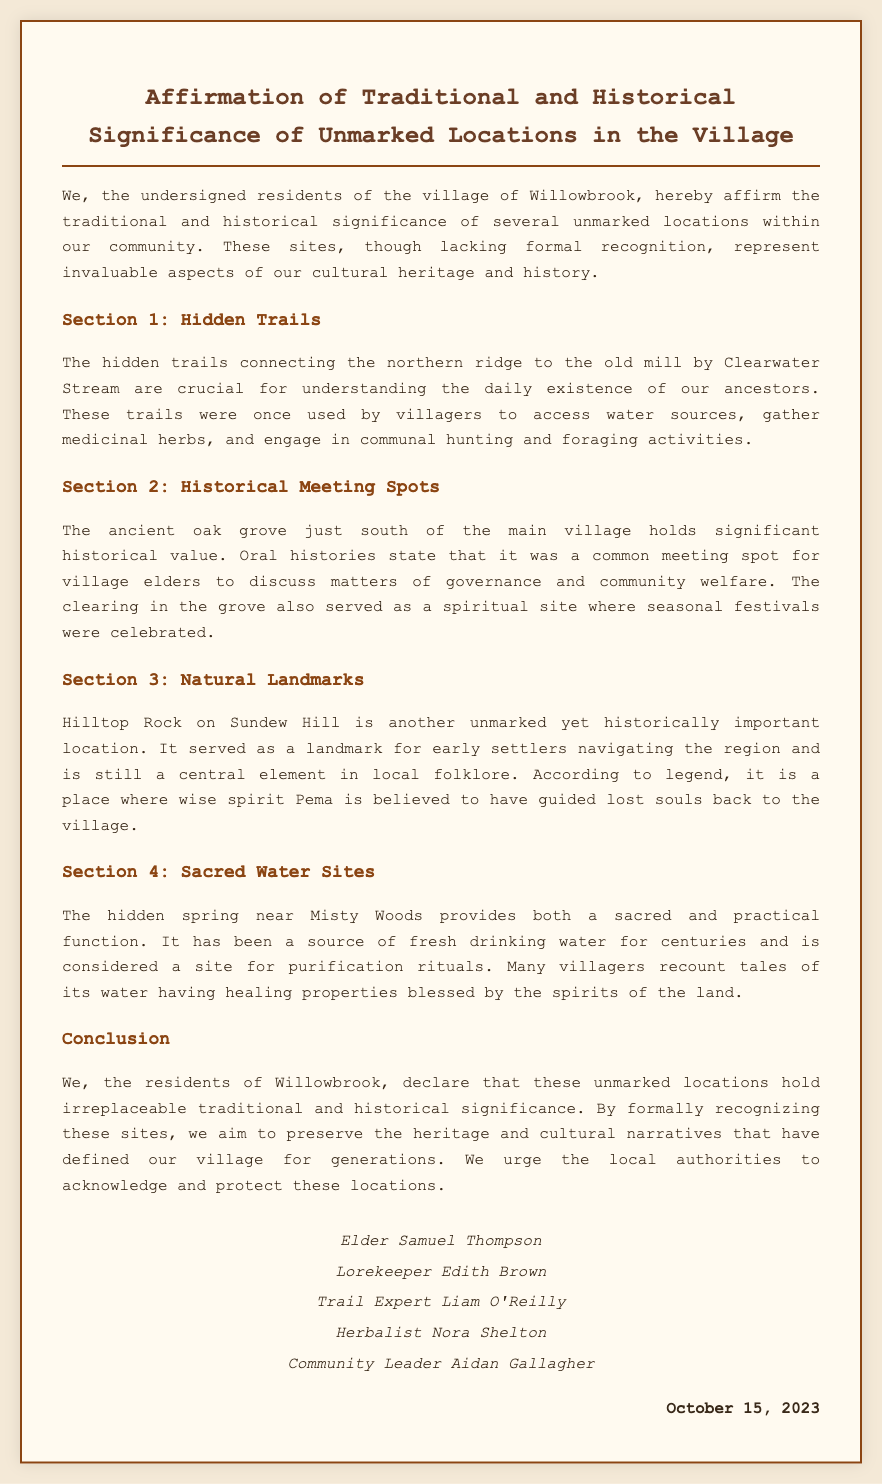What is the title of the document? The title is clearly stated at the top of the document.
Answer: Affirmation of Traditional and Historical Significance of Unmarked Locations in the Village Who signed the declaration? The document lists several residents who have signed the declaration.
Answer: Elder Samuel Thompson, Lorekeeper Edith Brown, Trail Expert Liam O'Reilly, Herbalist Nora Shelton, Community Leader Aidan Gallagher What is the date of the declaration? The date is mentioned at the bottom of the document.
Answer: October 15, 2023 What is the role of Liam O'Reilly? The document indicates the roles of individuals who signed, including Liam O'Reilly.
Answer: Trail Expert What is detailed in Section 2? Each section of the document addresses specific topics; Section 2 focuses on a particular site of importance.
Answer: Historical Meeting Spots What type of location is Hilltop Rock? The document describes Hilltop Rock in a specific context regarding its significance.
Answer: Natural Landmark What function does the hidden spring serve? The roles and significance of the hidden spring are outlined in the document.
Answer: Sacred and practical function Why is the ancient oak grove significant? The significance of the oak grove is explained in relation to community activities and history.
Answer: Meeting spot for village elders What do the residents urge local authorities to do? The conclusion summarizes the residents' request to local authorities regarding the unmarked locations.
Answer: Acknowledge and protect these locations 